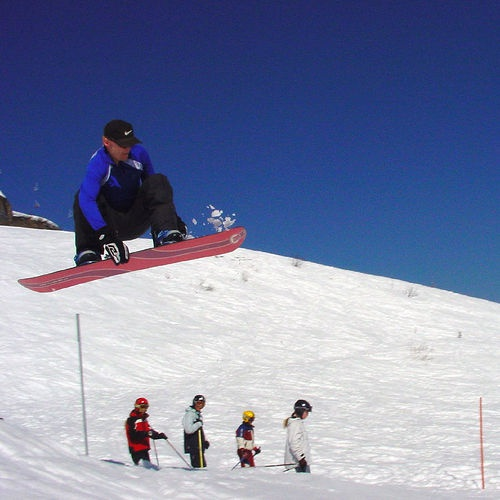Describe the objects in this image and their specific colors. I can see people in navy, black, darkblue, and gray tones, snowboard in navy, brown, and salmon tones, people in navy, black, lightgray, darkgray, and gray tones, people in navy, lightgray, darkgray, black, and gray tones, and people in navy, black, lightgray, maroon, and brown tones in this image. 